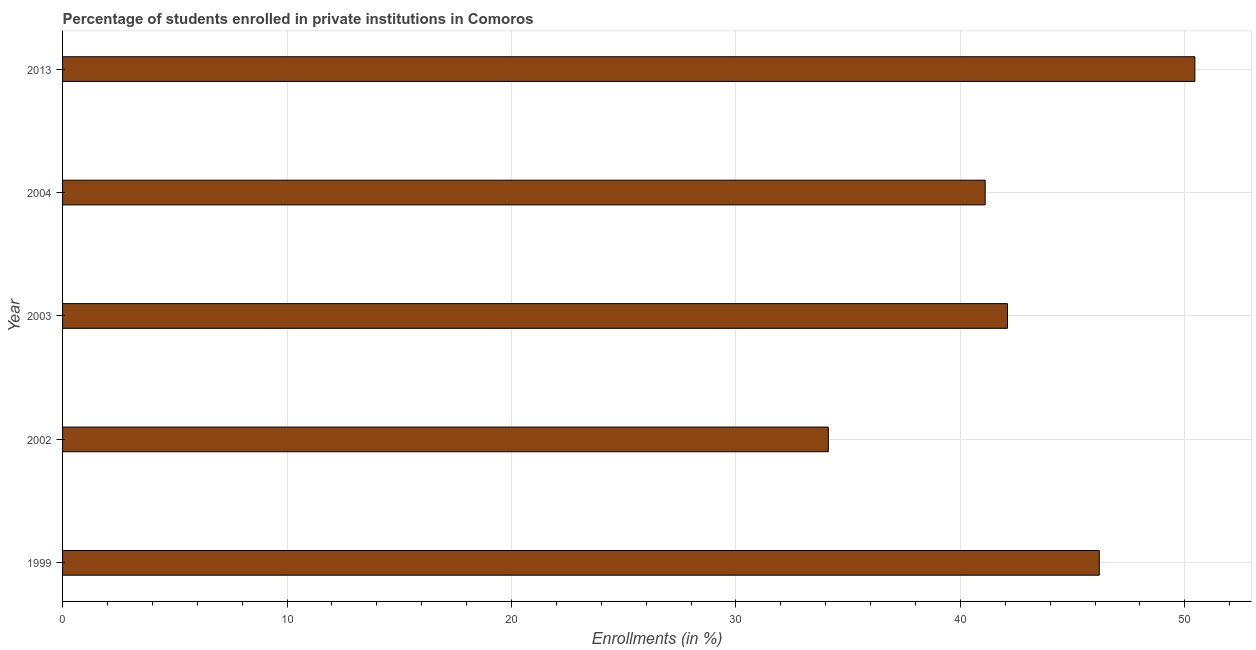Does the graph contain grids?
Provide a succinct answer. Yes. What is the title of the graph?
Give a very brief answer. Percentage of students enrolled in private institutions in Comoros. What is the label or title of the X-axis?
Your answer should be very brief. Enrollments (in %). What is the label or title of the Y-axis?
Your answer should be very brief. Year. What is the enrollments in private institutions in 2013?
Offer a terse response. 50.45. Across all years, what is the maximum enrollments in private institutions?
Provide a short and direct response. 50.45. Across all years, what is the minimum enrollments in private institutions?
Ensure brevity in your answer.  34.11. What is the sum of the enrollments in private institutions?
Give a very brief answer. 213.95. What is the difference between the enrollments in private institutions in 1999 and 2002?
Keep it short and to the point. 12.07. What is the average enrollments in private institutions per year?
Keep it short and to the point. 42.79. What is the median enrollments in private institutions?
Offer a very short reply. 42.1. What is the ratio of the enrollments in private institutions in 2004 to that in 2013?
Your answer should be compact. 0.81. Is the difference between the enrollments in private institutions in 1999 and 2003 greater than the difference between any two years?
Your response must be concise. No. What is the difference between the highest and the second highest enrollments in private institutions?
Make the answer very short. 4.26. What is the difference between the highest and the lowest enrollments in private institutions?
Provide a succinct answer. 16.33. In how many years, is the enrollments in private institutions greater than the average enrollments in private institutions taken over all years?
Offer a terse response. 2. Are all the bars in the graph horizontal?
Keep it short and to the point. Yes. How many years are there in the graph?
Offer a very short reply. 5. Are the values on the major ticks of X-axis written in scientific E-notation?
Keep it short and to the point. No. What is the Enrollments (in %) of 1999?
Provide a succinct answer. 46.19. What is the Enrollments (in %) in 2002?
Give a very brief answer. 34.11. What is the Enrollments (in %) in 2003?
Your answer should be very brief. 42.1. What is the Enrollments (in %) of 2004?
Keep it short and to the point. 41.1. What is the Enrollments (in %) of 2013?
Offer a terse response. 50.45. What is the difference between the Enrollments (in %) in 1999 and 2002?
Offer a very short reply. 12.07. What is the difference between the Enrollments (in %) in 1999 and 2003?
Give a very brief answer. 4.09. What is the difference between the Enrollments (in %) in 1999 and 2004?
Make the answer very short. 5.08. What is the difference between the Enrollments (in %) in 1999 and 2013?
Your answer should be very brief. -4.26. What is the difference between the Enrollments (in %) in 2002 and 2003?
Your answer should be compact. -7.98. What is the difference between the Enrollments (in %) in 2002 and 2004?
Offer a very short reply. -6.99. What is the difference between the Enrollments (in %) in 2002 and 2013?
Make the answer very short. -16.33. What is the difference between the Enrollments (in %) in 2003 and 2004?
Keep it short and to the point. 0.99. What is the difference between the Enrollments (in %) in 2003 and 2013?
Offer a very short reply. -8.35. What is the difference between the Enrollments (in %) in 2004 and 2013?
Your answer should be very brief. -9.34. What is the ratio of the Enrollments (in %) in 1999 to that in 2002?
Ensure brevity in your answer.  1.35. What is the ratio of the Enrollments (in %) in 1999 to that in 2003?
Give a very brief answer. 1.1. What is the ratio of the Enrollments (in %) in 1999 to that in 2004?
Your answer should be compact. 1.12. What is the ratio of the Enrollments (in %) in 1999 to that in 2013?
Your answer should be very brief. 0.92. What is the ratio of the Enrollments (in %) in 2002 to that in 2003?
Offer a terse response. 0.81. What is the ratio of the Enrollments (in %) in 2002 to that in 2004?
Provide a succinct answer. 0.83. What is the ratio of the Enrollments (in %) in 2002 to that in 2013?
Provide a short and direct response. 0.68. What is the ratio of the Enrollments (in %) in 2003 to that in 2004?
Keep it short and to the point. 1.02. What is the ratio of the Enrollments (in %) in 2003 to that in 2013?
Ensure brevity in your answer.  0.83. What is the ratio of the Enrollments (in %) in 2004 to that in 2013?
Your answer should be compact. 0.81. 